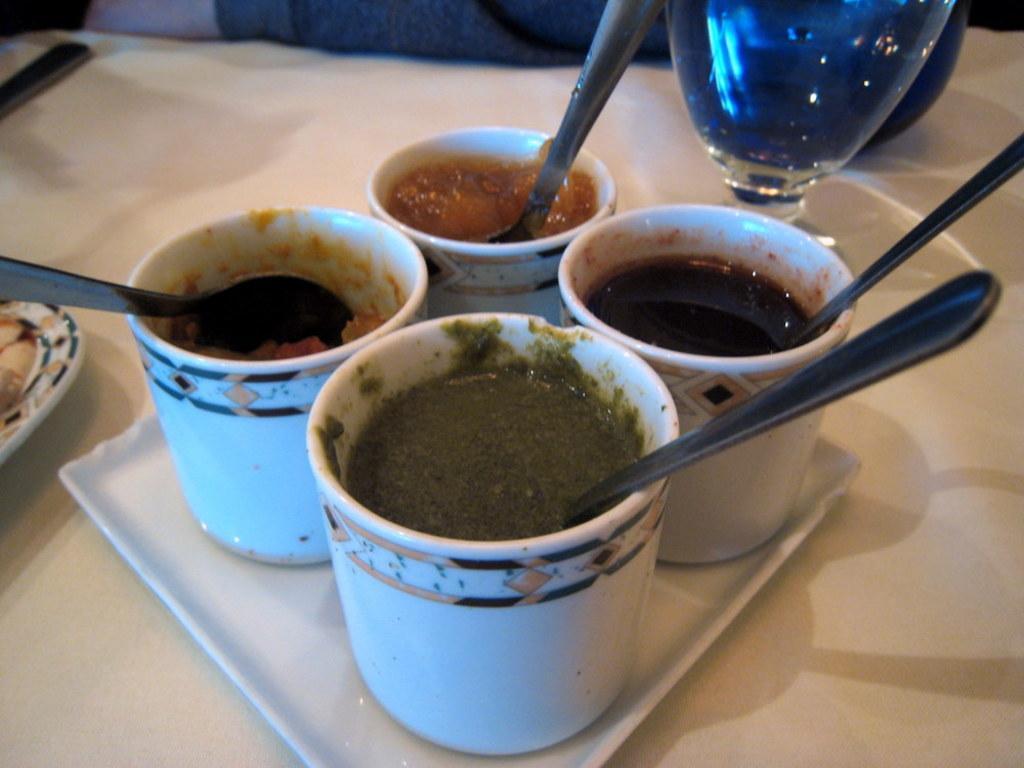Please provide a concise description of this image. In this picture we can see a tray on a platform, on this tray we can see cups with food, spoons in it and in the background we can see a glass, spoon and some objects. 